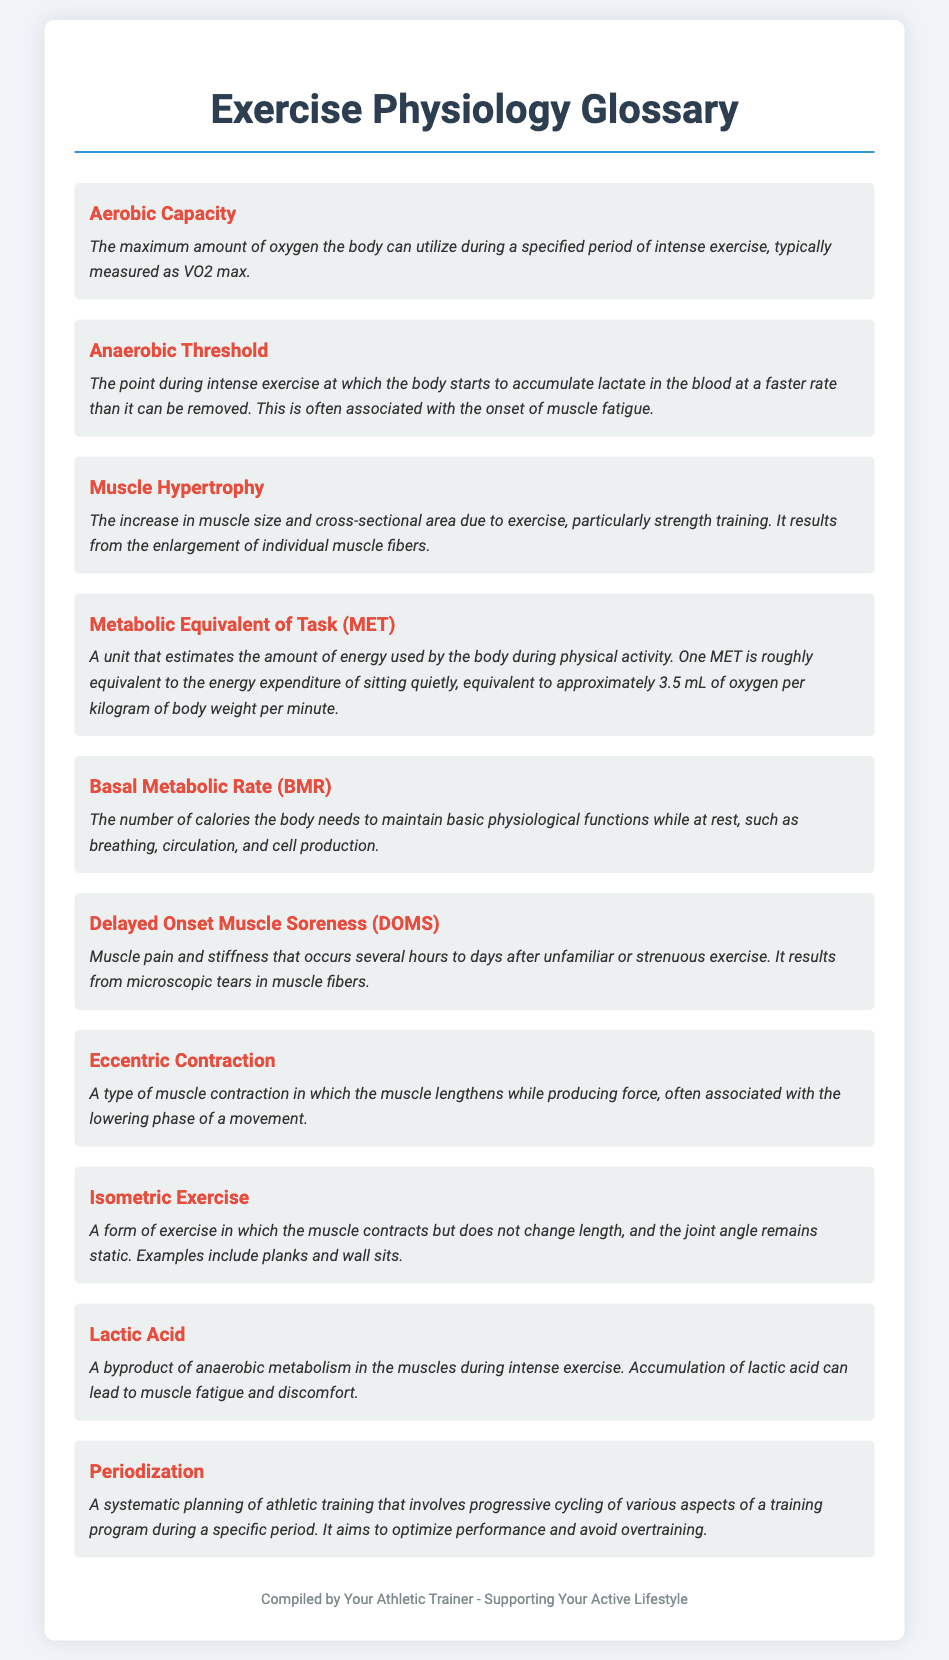what is the maximum amount of oxygen the body can utilize during intense exercise? This information is found under the term "Aerobic Capacity," which defines it as the maximum amount of oxygen utilized during intense exercise.
Answer: VO2 max what occurs during the Anaerobic Threshold? The definition describes the point during intense exercise where lactate accumulates faster than it can be removed, leading to fatigue.
Answer: Muscle fatigue what does one MET estimate? The document mentions that one MET is roughly equivalent to the energy expenditure of sitting quietly, a standard measurement in exercise.
Answer: Energy expenditure what type of muscle contraction is described as lengthening while producing force? This type of contraction is referred to in the definition of "Eccentric Contraction."
Answer: Eccentric Contraction what is the number of calories the body needs at rest to maintain basic functions? This is described under the term "Basal Metabolic Rate (BMR)," which defines what BMR represents.
Answer: Basal Metabolic Rate what causes Delayed Onset Muscle Soreness (DOMS)? The definition indicates that DOMS results from microscopic tears in muscle fibers after strenuous exercise.
Answer: Microscopic tears how does Periodization aim to optimize athletic training? The term "Periodization" specifies that it involves systematic planning of training programs to optimize performance and avoid overtraining.
Answer: Optimize performance what is an example of an isometric exercise? The definition lists planks and wall sits as examples under the term "Isometric Exercise."
Answer: Planks what is a byproduct of anaerobic metabolism during intense exercise? The document mentions Lactic Acid as a byproduct associated with anaerobic metabolism.
Answer: Lactic Acid 